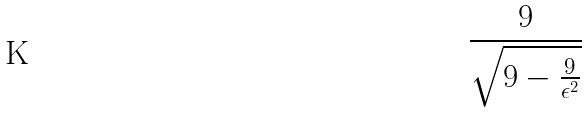<formula> <loc_0><loc_0><loc_500><loc_500>\frac { 9 } { \sqrt { 9 - \frac { 9 } { \epsilon ^ { 2 } } } }</formula> 